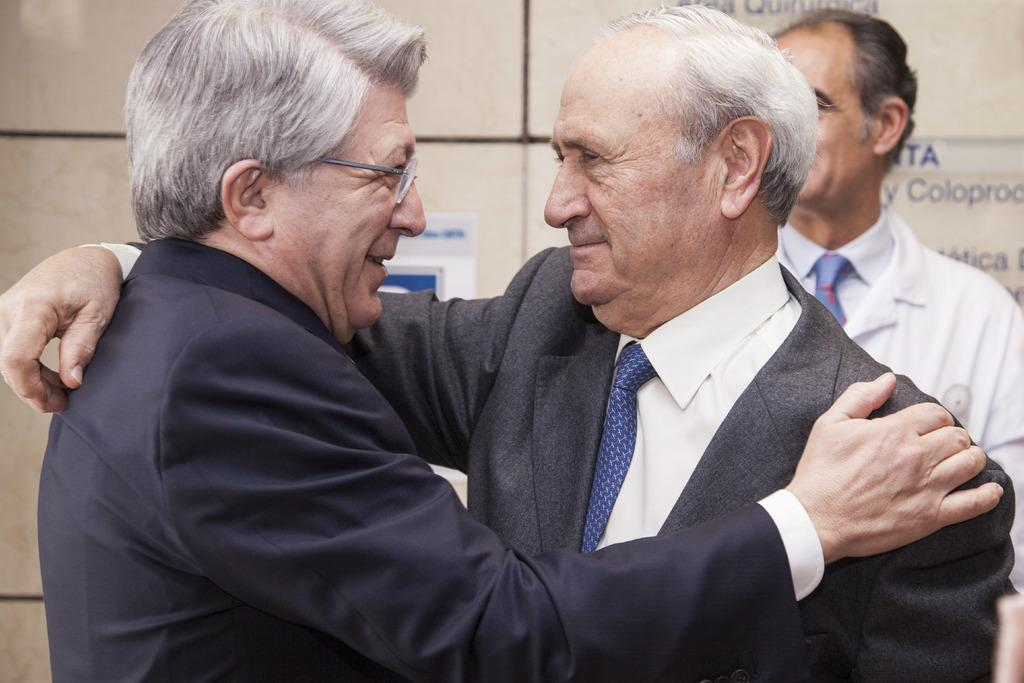How many men are present in the image? There are two men standing in the image. Can you describe the position of the third man in the image? There is a man in the background on the right side. What can be seen on the wall in the background? There are boards on the wall in the background. What statement is being made by the men in the image? There is no statement being made by the men in the image; they are simply standing in the scene. 